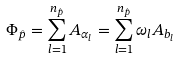<formula> <loc_0><loc_0><loc_500><loc_500>\Phi _ { \hat { p } } = \sum _ { l = 1 } ^ { n _ { \hat { p } } } A _ { \alpha _ { l } } = \sum _ { l = 1 } ^ { n _ { \hat { p } } } \omega _ { l } A _ { b _ { l } }</formula> 